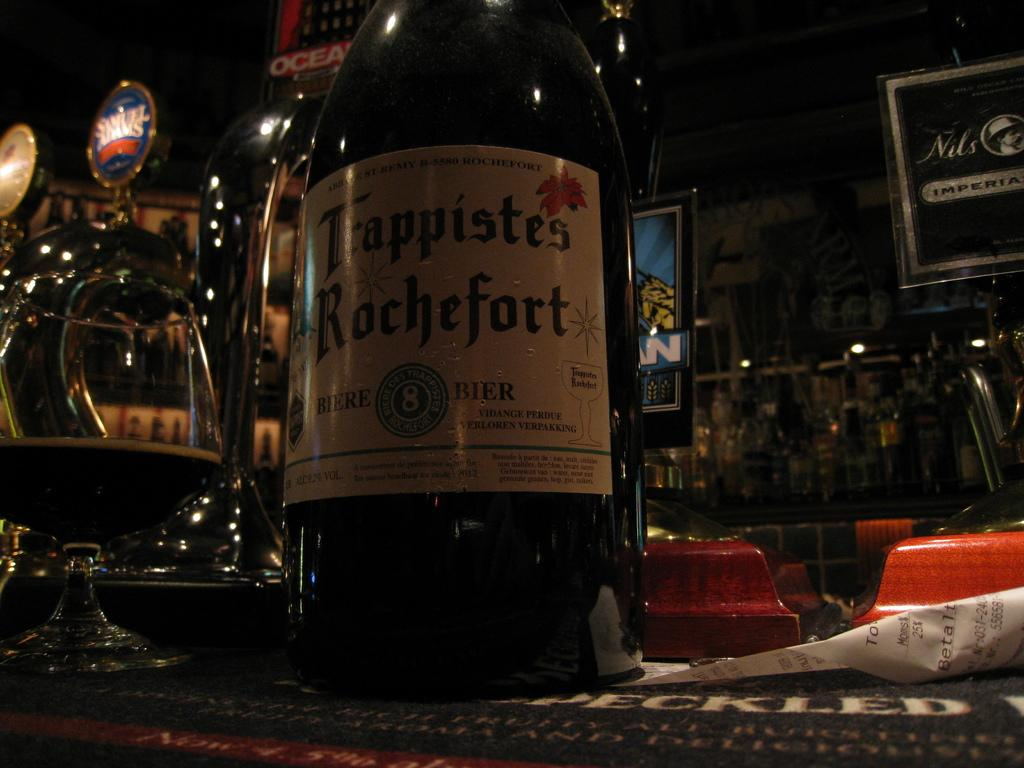<image>
Summarize the visual content of the image. Trappistes Rochefort is the name on the label of this liquor bottle. 